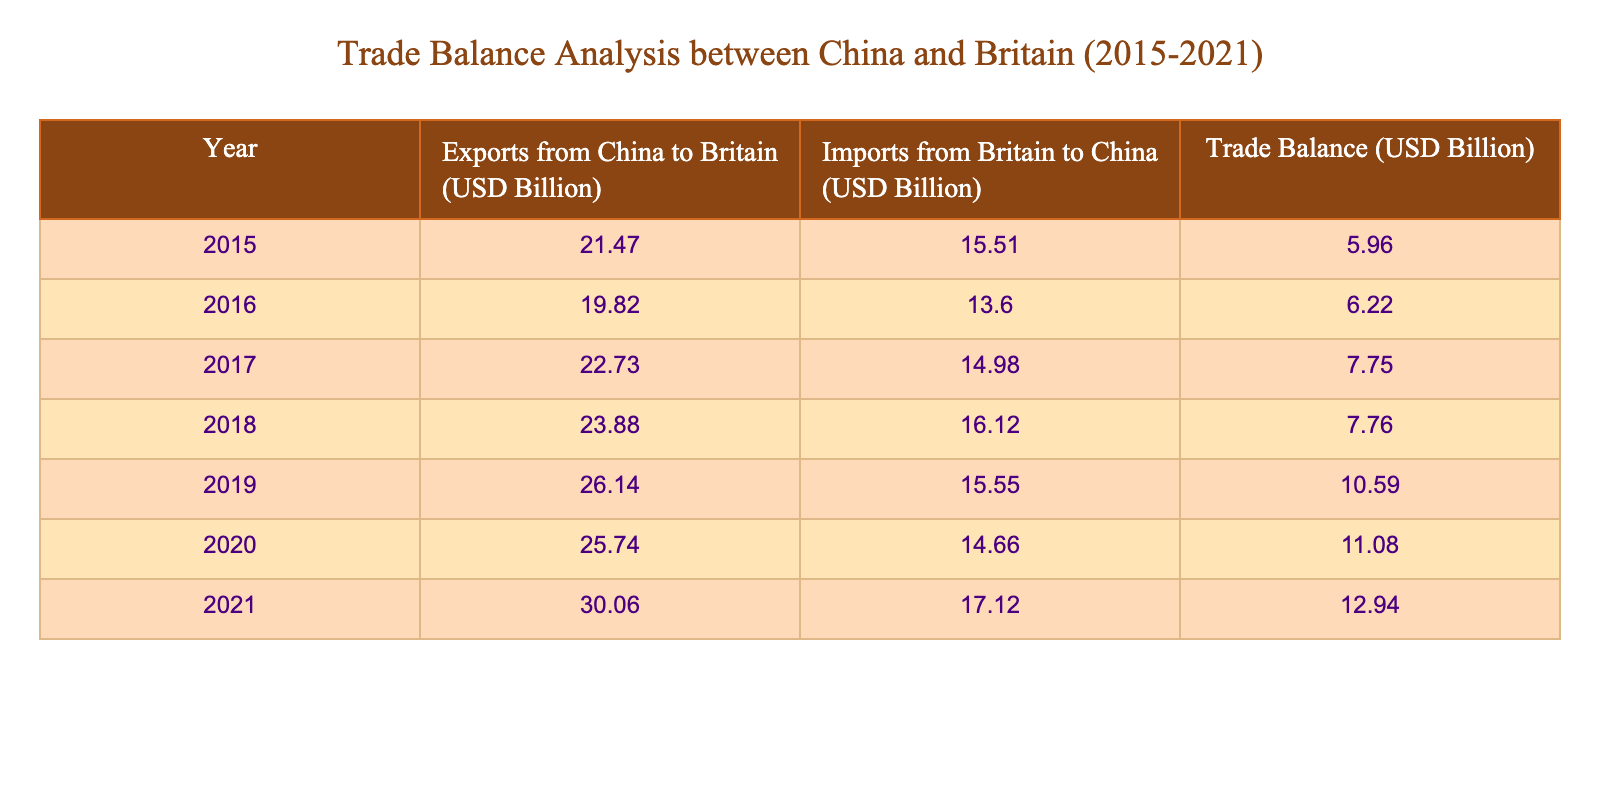What was the trade balance in 2019? The trade balance for the year 2019 is found directly in the table under the "Trade Balance" column, which indicates a value of 10.59 billion USD.
Answer: 10.59 billion USD What year saw the highest exports from China to Britain? By comparing the values in the "Exports from China to Britain" column, the highest value is 30.06 billion USD, which occurred in the year 2021.
Answer: 2021 What is the difference in imports from Britain to China between 2015 and 2021? The import value for 2015 is 15.51 billion USD and for 2021 is 17.12 billion USD. The difference is calculated as 17.12 - 15.51 = 1.61 billion USD.
Answer: 1.61 billion USD Did the trade balance increase every year from 2015 to 2021? To determine this, we need to look at the "Trade Balance" values for each year: 5.96, 6.22, 7.75, 7.76, 10.59, 11.08, and 12.94. The values show that there are some increases, but the trade balance did not decrease at any point. Thus, it can be concluded that the trade balance increased every year.
Answer: Yes What were the total exports from China to Britain over the years 2015 to 2021? The exports are: 21.47, 19.82, 22.73, 23.88, 26.14, 25.74, and 30.06 billion USD. Summing these values gives: 21.47 + 19.82 + 22.73 + 23.88 + 26.14 + 25.74 + 30.06 = 169.84 billion USD.
Answer: 169.84 billion USD What was the average trade balance from 2015 to 2021? The trade balance values are: 5.96, 6.22, 7.75, 7.76, 10.59, 11.08, and 12.94 billion USD. Adding these gives 5.96 + 6.22 + 7.75 + 7.76 + 10.59 + 11.08 + 12.94 = 62.30 billion USD. Dividing by the number of years (7) results in an average of approximately 8.9 billion USD.
Answer: Approximately 8.9 billion USD Which year had the lowest imports from Britain to China? Looking at the "Imports from Britain to China" column, 2016 has the lowest value at 13.60 billion USD compared to other years.
Answer: 2016 Did the exports from China to Britain exceed 25 billion USD in 2020? In 2020, the exports were 25.74 billion USD. Since this is greater than 25 billion USD, the statement is true.
Answer: Yes 